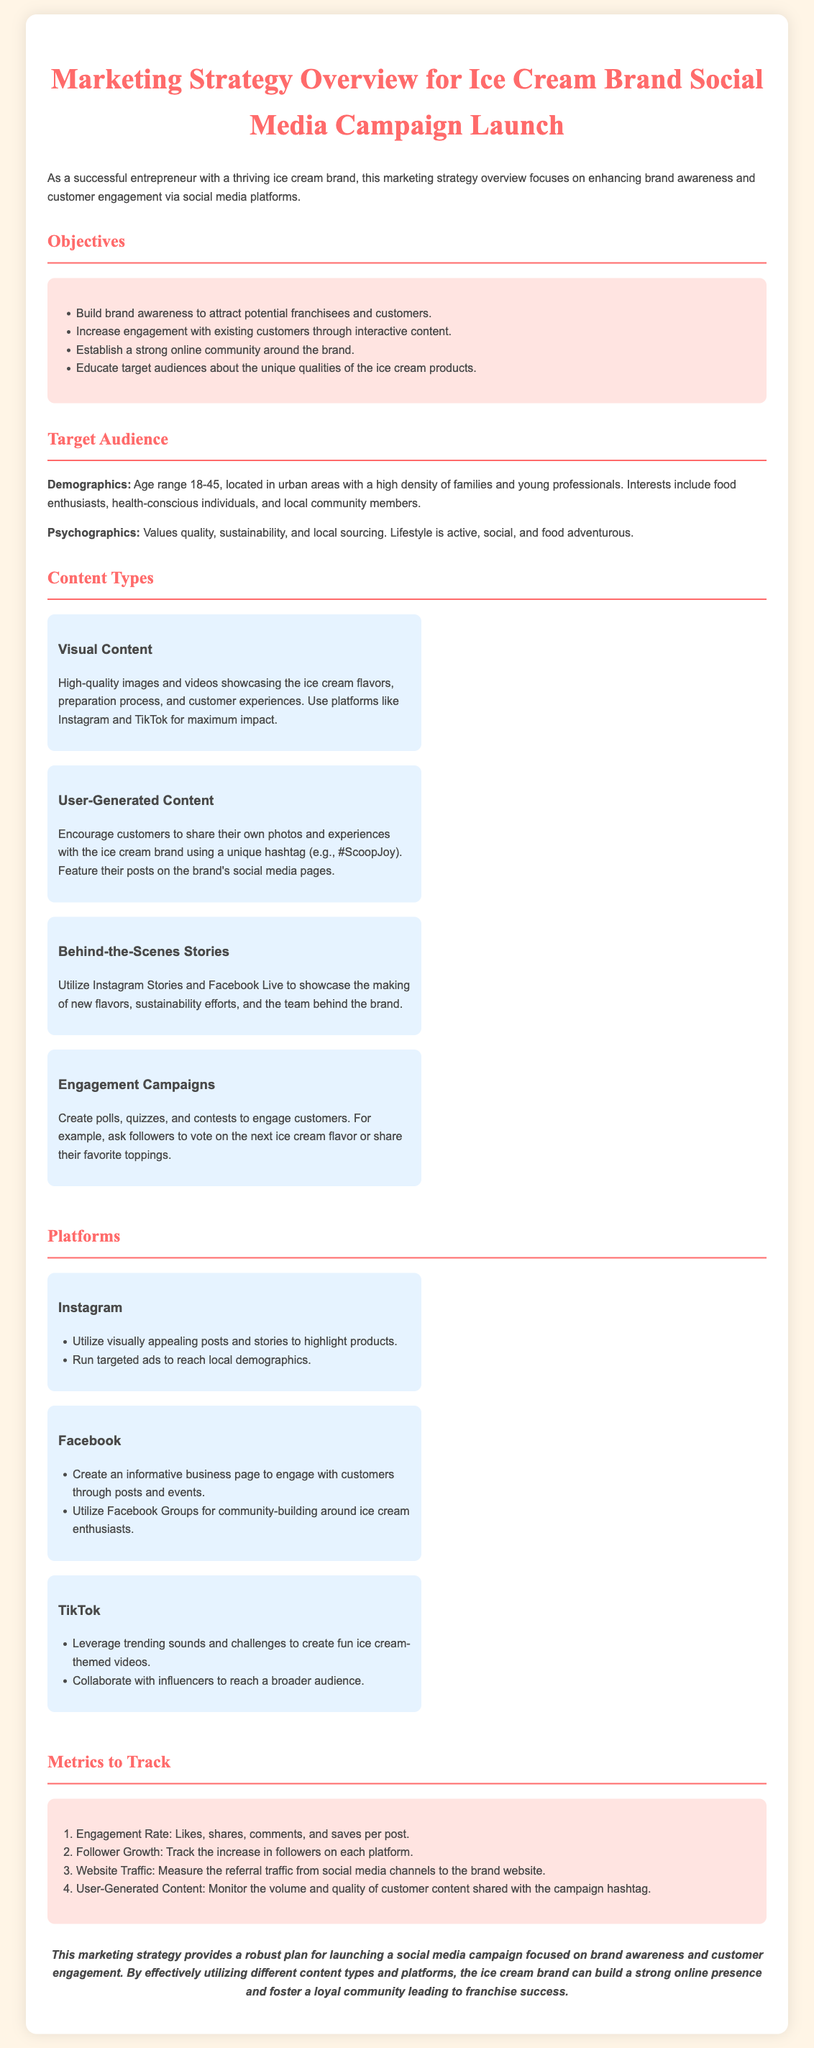What are the main objectives of the marketing strategy? The document lists objectives including building brand awareness, increasing engagement, establishing an online community, and educating audiences.
Answer: Brand awareness, engagement, community, education What age range does the target audience fall into? The document specifies the target audience's age range as part of the demographics section.
Answer: 18-45 Which social media platform emphasizes visually appealing posts? The document mentions Instagram as the platform ideal for visually appealing content.
Answer: Instagram What type of content encourages customers to share experiences? The document identifies user-generated content as a type of content that prompts sharing.
Answer: User-Generated Content What metric tracks the increase in followers on each platform? The document lists follower growth as a key metric to track social media success.
Answer: Follower Growth How many content types are mentioned in the document? The document outlines four distinct content types as part of the strategy.
Answer: Four What does the engagement rate measure? The document describes the engagement rate as including likes, shares, comments, and saves per post.
Answer: Likes, shares, comments, saves Which platform is recommended for community building? The document suggests that Facebook Groups are effective for building community around ice cream enthusiasts.
Answer: Facebook What color is used for the document's headings? The document indicates that the color used for headings is a specific shade of red.
Answer: Red 